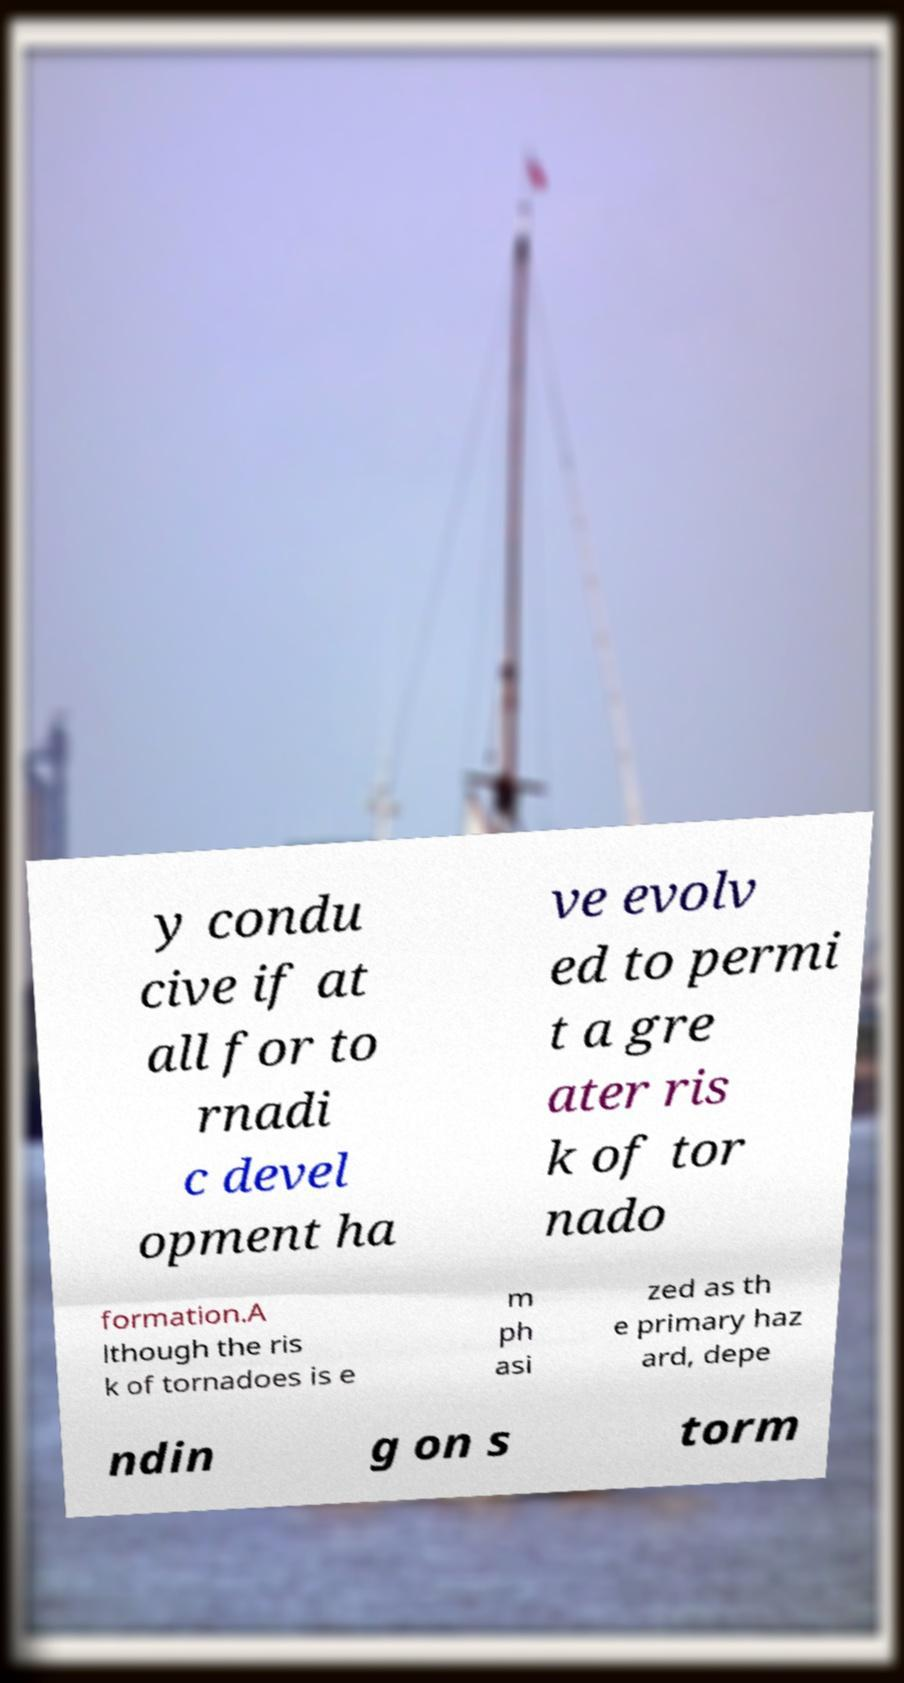For documentation purposes, I need the text within this image transcribed. Could you provide that? y condu cive if at all for to rnadi c devel opment ha ve evolv ed to permi t a gre ater ris k of tor nado formation.A lthough the ris k of tornadoes is e m ph asi zed as th e primary haz ard, depe ndin g on s torm 